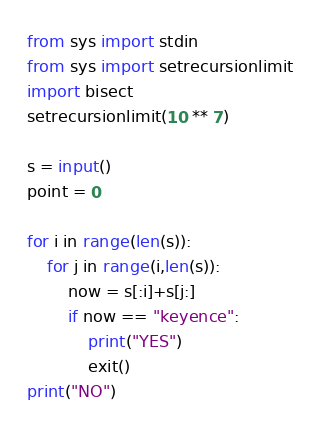Convert code to text. <code><loc_0><loc_0><loc_500><loc_500><_Python_>from sys import stdin
from sys import setrecursionlimit
import bisect
setrecursionlimit(10 ** 7)

s = input()
point = 0

for i in range(len(s)):
    for j in range(i,len(s)):
        now = s[:i]+s[j:]
        if now == "keyence":
            print("YES")
            exit()
print("NO")</code> 